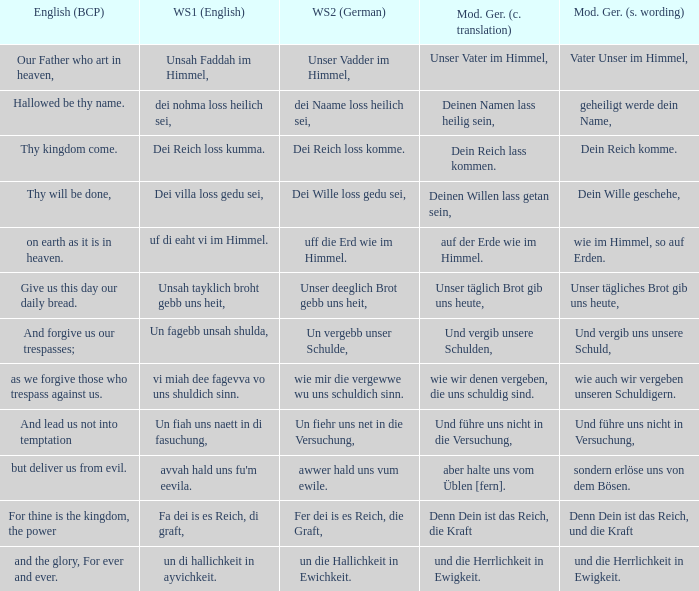What is the modern german standard wording for the german based writing system 2 phrase "wie mir die vergewwe wu uns schuldich sinn."? Wie auch wir vergeben unseren schuldigern. 